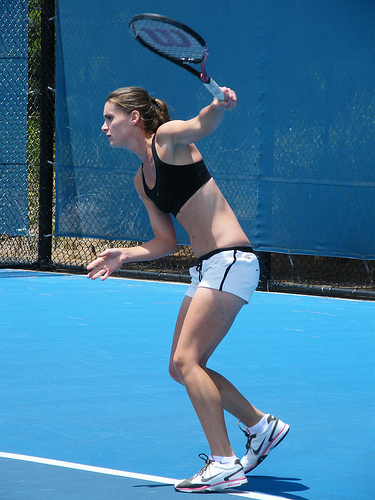Are there either papers or tents? No, the image does not contain any papers or tents, focusing exclusively on the athletic activity of tennis. 